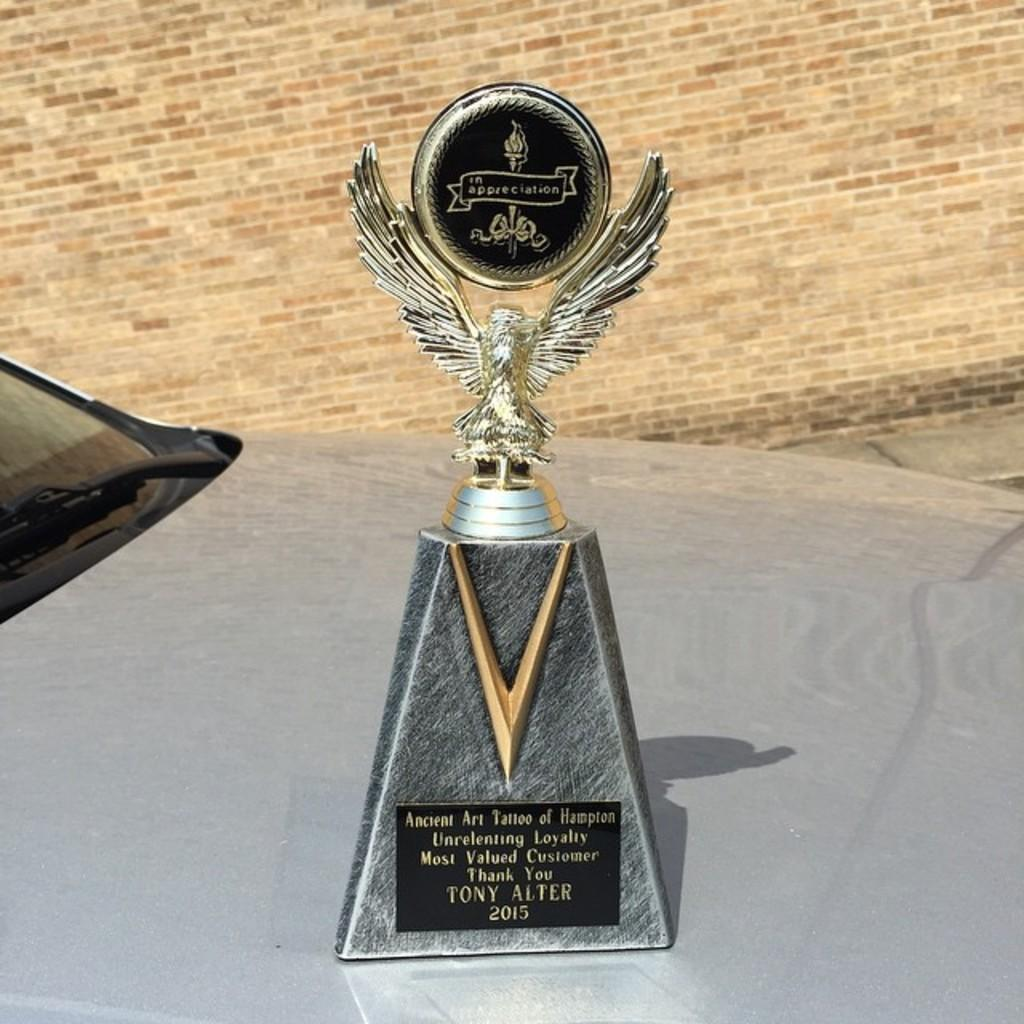<image>
Relay a brief, clear account of the picture shown. A trophy that is awarded to Tony Alter. 